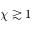<formula> <loc_0><loc_0><loc_500><loc_500>\chi \gtrsim 1</formula> 